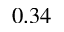Convert formula to latex. <formula><loc_0><loc_0><loc_500><loc_500>0 . 3 4</formula> 